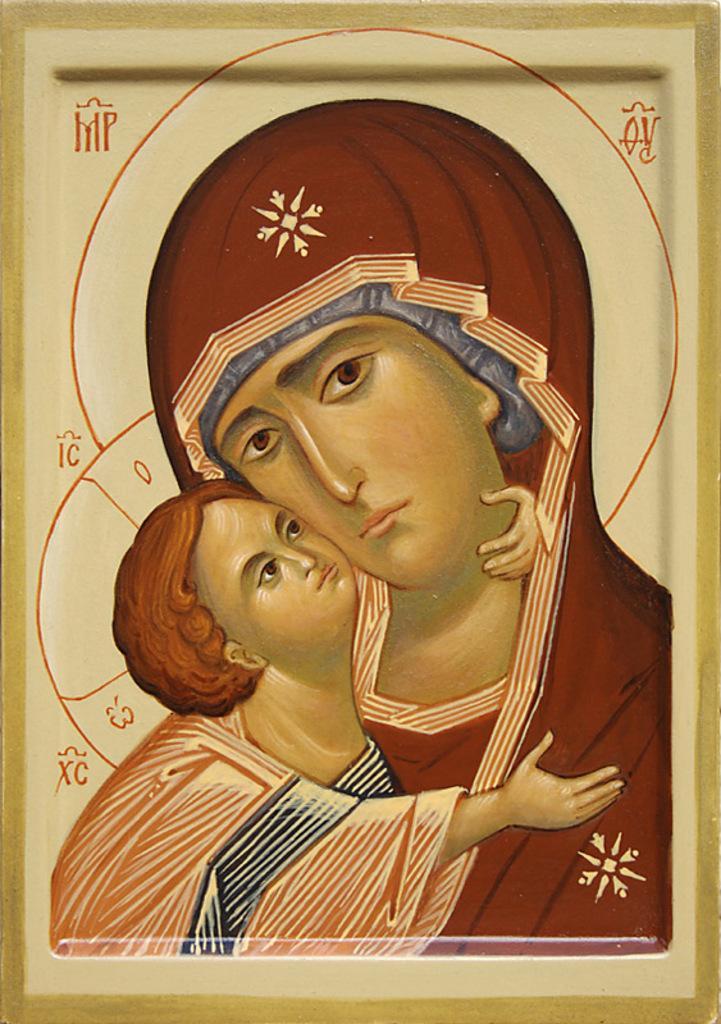Could you give a brief overview of what you see in this image? In this image there is a poster we can see there is one woman holding a baby. 